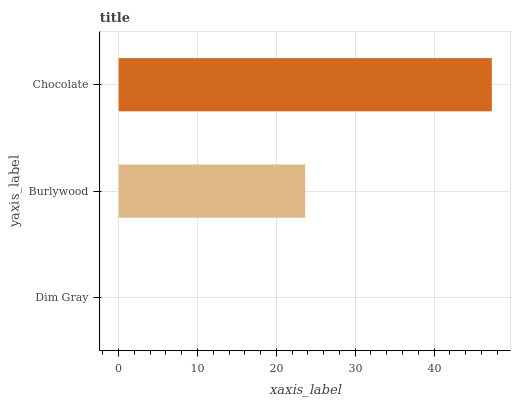Is Dim Gray the minimum?
Answer yes or no. Yes. Is Chocolate the maximum?
Answer yes or no. Yes. Is Burlywood the minimum?
Answer yes or no. No. Is Burlywood the maximum?
Answer yes or no. No. Is Burlywood greater than Dim Gray?
Answer yes or no. Yes. Is Dim Gray less than Burlywood?
Answer yes or no. Yes. Is Dim Gray greater than Burlywood?
Answer yes or no. No. Is Burlywood less than Dim Gray?
Answer yes or no. No. Is Burlywood the high median?
Answer yes or no. Yes. Is Burlywood the low median?
Answer yes or no. Yes. Is Chocolate the high median?
Answer yes or no. No. Is Dim Gray the low median?
Answer yes or no. No. 